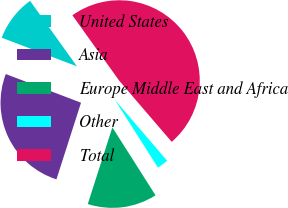<chart> <loc_0><loc_0><loc_500><loc_500><pie_chart><fcel>United States<fcel>Asia<fcel>Europe Middle East and Africa<fcel>Other<fcel>Total<nl><fcel>9.32%<fcel>25.85%<fcel>13.95%<fcel>2.28%<fcel>48.6%<nl></chart> 